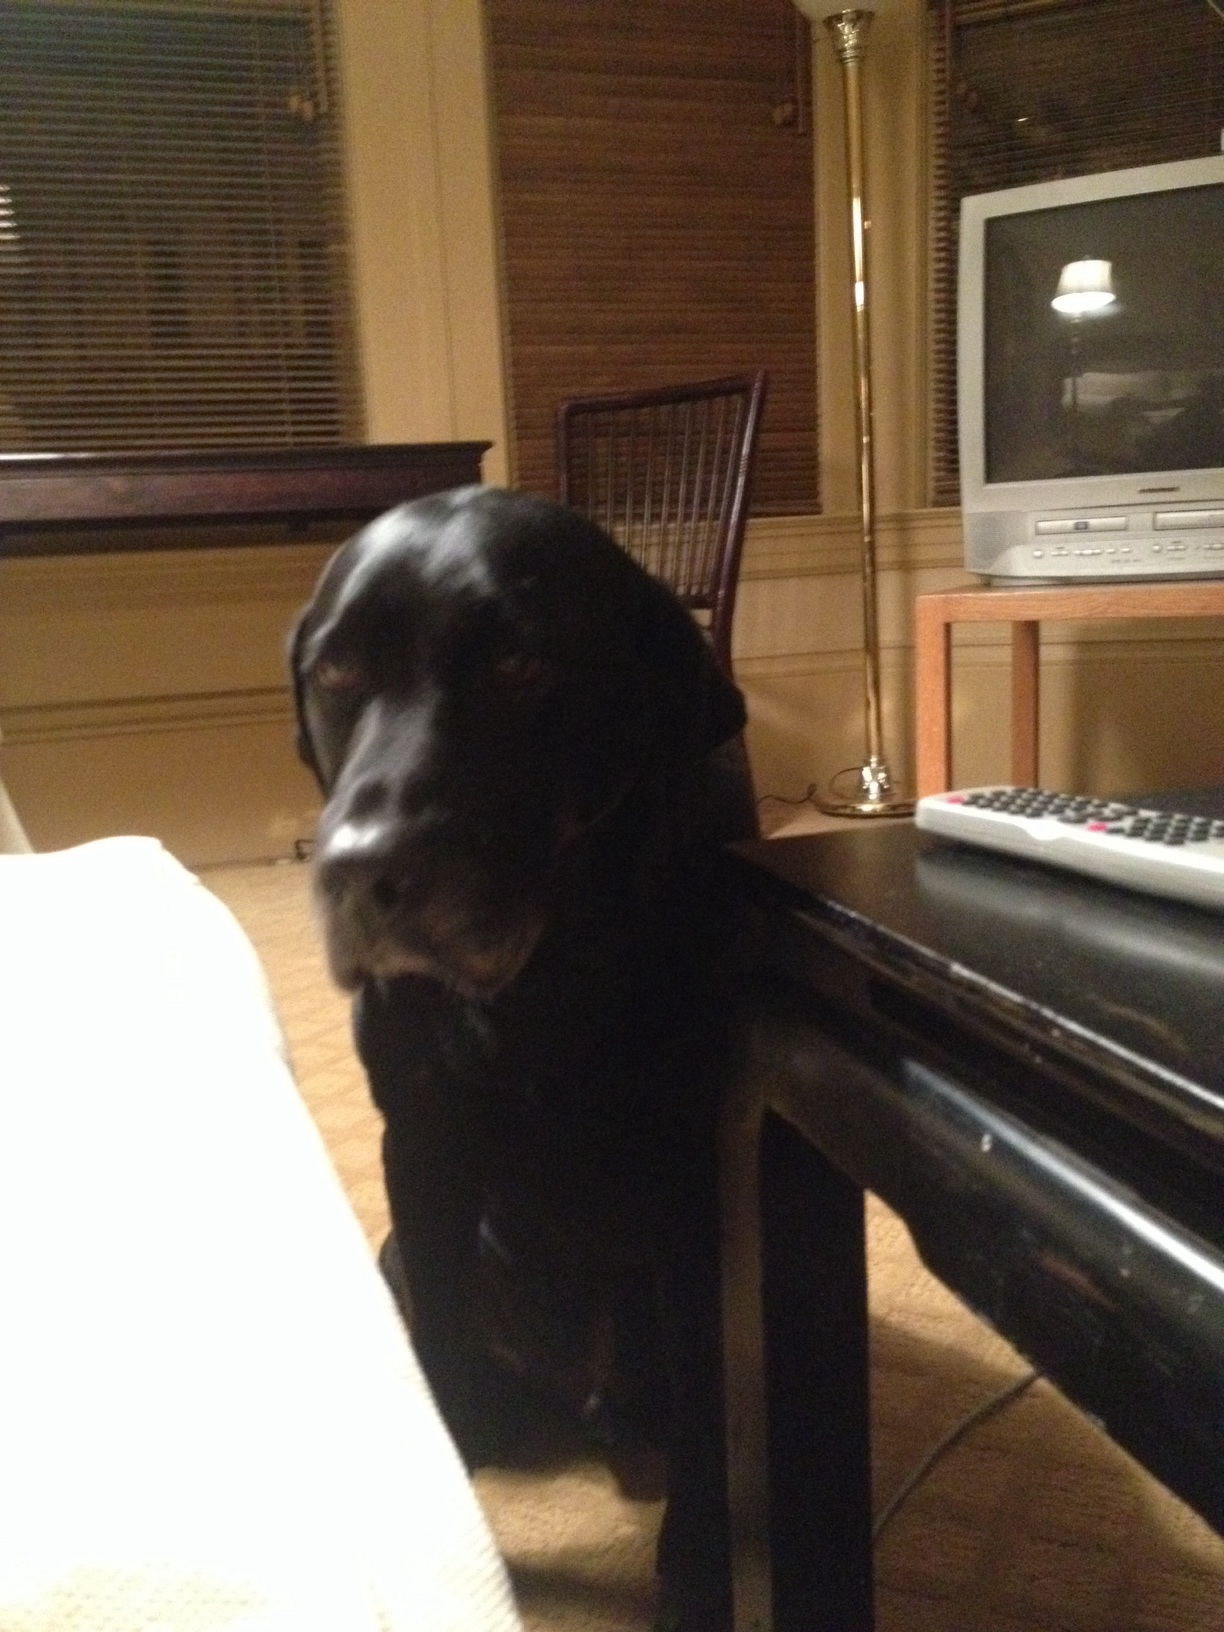How does the dog seem to be feeling in the picture? The dog’s eyes are open and attentive, and its posture is relaxed, suggesting it is calm and comfortable in its environment, perhaps used to being around people and the camera. 